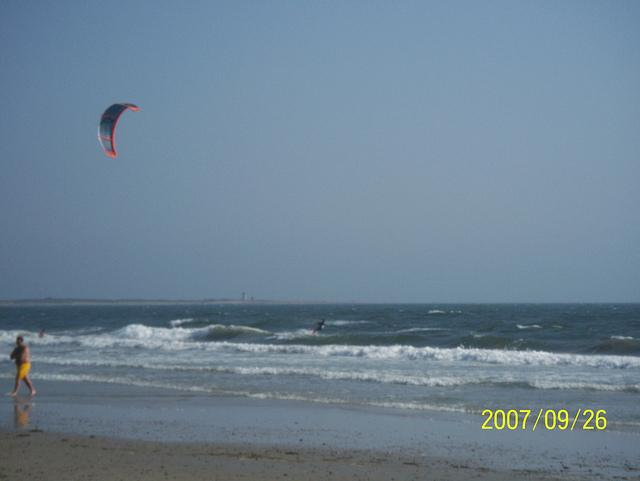How much older is this man now? Please explain your reasoning. 14 years. The photo was taken in 2007. 